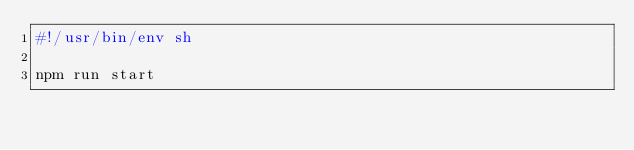Convert code to text. <code><loc_0><loc_0><loc_500><loc_500><_Bash_>#!/usr/bin/env sh

npm run start</code> 